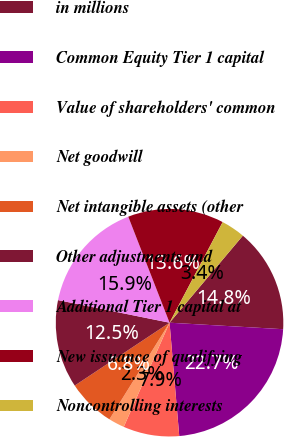Convert chart. <chart><loc_0><loc_0><loc_500><loc_500><pie_chart><fcel>in millions<fcel>Common Equity Tier 1 capital<fcel>Value of shareholders' common<fcel>Net goodwill<fcel>Net intangible assets (other<fcel>Other adjustments and<fcel>Additional Tier 1 capital at<fcel>New issuance of qualifying<fcel>Noncontrolling interests<nl><fcel>14.77%<fcel>22.73%<fcel>7.95%<fcel>2.27%<fcel>6.82%<fcel>12.5%<fcel>15.91%<fcel>13.64%<fcel>3.41%<nl></chart> 